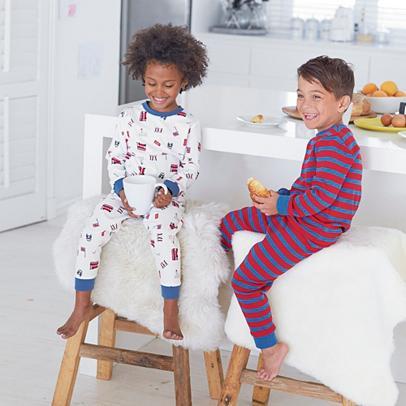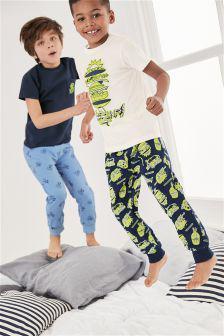The first image is the image on the left, the second image is the image on the right. For the images displayed, is the sentence "A boy and girl in the image on the left are sitting down." factually correct? Answer yes or no. Yes. 